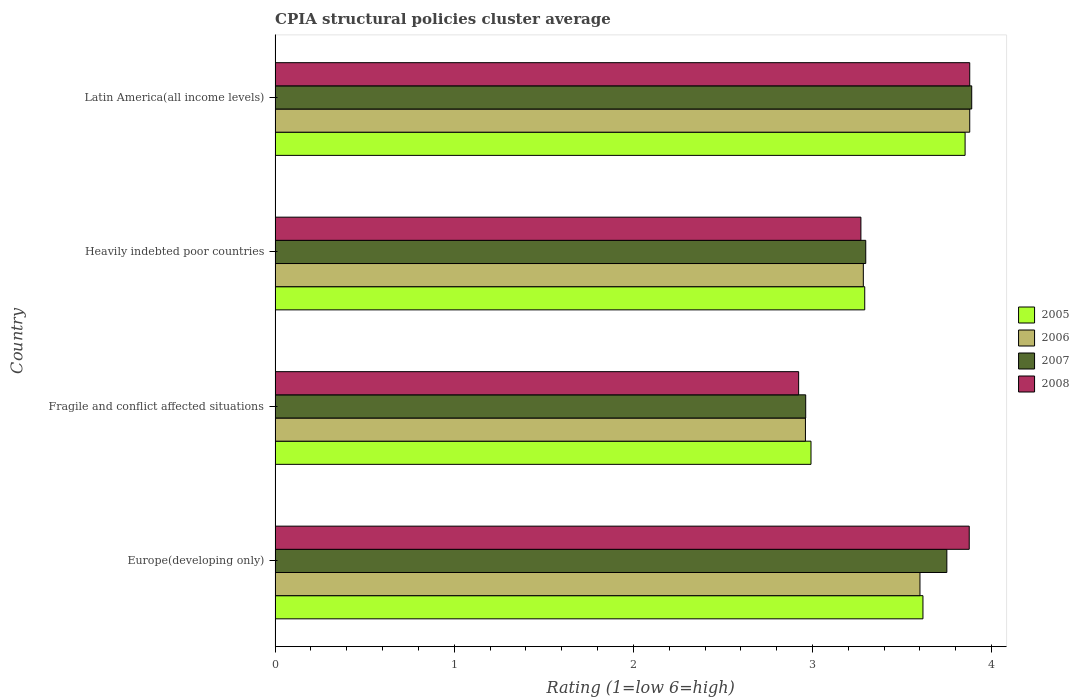How many groups of bars are there?
Give a very brief answer. 4. Are the number of bars per tick equal to the number of legend labels?
Provide a short and direct response. Yes. Are the number of bars on each tick of the Y-axis equal?
Your answer should be compact. Yes. How many bars are there on the 3rd tick from the top?
Keep it short and to the point. 4. What is the label of the 3rd group of bars from the top?
Provide a short and direct response. Fragile and conflict affected situations. In how many cases, is the number of bars for a given country not equal to the number of legend labels?
Make the answer very short. 0. What is the CPIA rating in 2008 in Europe(developing only)?
Provide a short and direct response. 3.88. Across all countries, what is the maximum CPIA rating in 2006?
Make the answer very short. 3.88. Across all countries, what is the minimum CPIA rating in 2005?
Ensure brevity in your answer.  2.99. In which country was the CPIA rating in 2006 maximum?
Offer a very short reply. Latin America(all income levels). In which country was the CPIA rating in 2005 minimum?
Your answer should be very brief. Fragile and conflict affected situations. What is the total CPIA rating in 2007 in the graph?
Keep it short and to the point. 13.9. What is the difference between the CPIA rating in 2007 in Europe(developing only) and that in Fragile and conflict affected situations?
Offer a terse response. 0.79. What is the difference between the CPIA rating in 2007 in Latin America(all income levels) and the CPIA rating in 2005 in Fragile and conflict affected situations?
Ensure brevity in your answer.  0.9. What is the average CPIA rating in 2008 per country?
Offer a very short reply. 3.49. What is the difference between the CPIA rating in 2007 and CPIA rating in 2005 in Latin America(all income levels)?
Make the answer very short. 0.04. What is the ratio of the CPIA rating in 2006 in Heavily indebted poor countries to that in Latin America(all income levels)?
Keep it short and to the point. 0.85. What is the difference between the highest and the second highest CPIA rating in 2007?
Provide a succinct answer. 0.14. What is the difference between the highest and the lowest CPIA rating in 2007?
Give a very brief answer. 0.93. In how many countries, is the CPIA rating in 2006 greater than the average CPIA rating in 2006 taken over all countries?
Your response must be concise. 2. Is the sum of the CPIA rating in 2005 in Europe(developing only) and Latin America(all income levels) greater than the maximum CPIA rating in 2006 across all countries?
Keep it short and to the point. Yes. Is it the case that in every country, the sum of the CPIA rating in 2005 and CPIA rating in 2007 is greater than the sum of CPIA rating in 2006 and CPIA rating in 2008?
Provide a short and direct response. No. Is it the case that in every country, the sum of the CPIA rating in 2005 and CPIA rating in 2007 is greater than the CPIA rating in 2006?
Make the answer very short. Yes. How many bars are there?
Your answer should be compact. 16. Are all the bars in the graph horizontal?
Provide a short and direct response. Yes. Are the values on the major ticks of X-axis written in scientific E-notation?
Provide a succinct answer. No. Does the graph contain grids?
Provide a succinct answer. No. Where does the legend appear in the graph?
Provide a short and direct response. Center right. How many legend labels are there?
Offer a terse response. 4. What is the title of the graph?
Ensure brevity in your answer.  CPIA structural policies cluster average. What is the Rating (1=low 6=high) in 2005 in Europe(developing only)?
Your response must be concise. 3.62. What is the Rating (1=low 6=high) of 2006 in Europe(developing only)?
Offer a very short reply. 3.6. What is the Rating (1=low 6=high) of 2007 in Europe(developing only)?
Make the answer very short. 3.75. What is the Rating (1=low 6=high) of 2008 in Europe(developing only)?
Offer a very short reply. 3.88. What is the Rating (1=low 6=high) of 2005 in Fragile and conflict affected situations?
Make the answer very short. 2.99. What is the Rating (1=low 6=high) of 2006 in Fragile and conflict affected situations?
Offer a very short reply. 2.96. What is the Rating (1=low 6=high) in 2007 in Fragile and conflict affected situations?
Give a very brief answer. 2.96. What is the Rating (1=low 6=high) in 2008 in Fragile and conflict affected situations?
Make the answer very short. 2.92. What is the Rating (1=low 6=high) in 2005 in Heavily indebted poor countries?
Keep it short and to the point. 3.29. What is the Rating (1=low 6=high) of 2006 in Heavily indebted poor countries?
Provide a short and direct response. 3.28. What is the Rating (1=low 6=high) in 2007 in Heavily indebted poor countries?
Provide a short and direct response. 3.3. What is the Rating (1=low 6=high) of 2008 in Heavily indebted poor countries?
Your answer should be compact. 3.27. What is the Rating (1=low 6=high) in 2005 in Latin America(all income levels)?
Provide a short and direct response. 3.85. What is the Rating (1=low 6=high) in 2006 in Latin America(all income levels)?
Your answer should be very brief. 3.88. What is the Rating (1=low 6=high) in 2007 in Latin America(all income levels)?
Provide a succinct answer. 3.89. What is the Rating (1=low 6=high) in 2008 in Latin America(all income levels)?
Offer a very short reply. 3.88. Across all countries, what is the maximum Rating (1=low 6=high) in 2005?
Offer a very short reply. 3.85. Across all countries, what is the maximum Rating (1=low 6=high) of 2006?
Give a very brief answer. 3.88. Across all countries, what is the maximum Rating (1=low 6=high) of 2007?
Your answer should be compact. 3.89. Across all countries, what is the maximum Rating (1=low 6=high) in 2008?
Your response must be concise. 3.88. Across all countries, what is the minimum Rating (1=low 6=high) of 2005?
Provide a succinct answer. 2.99. Across all countries, what is the minimum Rating (1=low 6=high) of 2006?
Give a very brief answer. 2.96. Across all countries, what is the minimum Rating (1=low 6=high) of 2007?
Provide a short and direct response. 2.96. Across all countries, what is the minimum Rating (1=low 6=high) of 2008?
Offer a very short reply. 2.92. What is the total Rating (1=low 6=high) in 2005 in the graph?
Give a very brief answer. 13.75. What is the total Rating (1=low 6=high) in 2006 in the graph?
Give a very brief answer. 13.72. What is the total Rating (1=low 6=high) in 2007 in the graph?
Provide a short and direct response. 13.9. What is the total Rating (1=low 6=high) in 2008 in the graph?
Offer a very short reply. 13.95. What is the difference between the Rating (1=low 6=high) in 2005 in Europe(developing only) and that in Fragile and conflict affected situations?
Ensure brevity in your answer.  0.62. What is the difference between the Rating (1=low 6=high) of 2006 in Europe(developing only) and that in Fragile and conflict affected situations?
Ensure brevity in your answer.  0.64. What is the difference between the Rating (1=low 6=high) in 2007 in Europe(developing only) and that in Fragile and conflict affected situations?
Provide a succinct answer. 0.79. What is the difference between the Rating (1=low 6=high) in 2008 in Europe(developing only) and that in Fragile and conflict affected situations?
Provide a succinct answer. 0.95. What is the difference between the Rating (1=low 6=high) of 2005 in Europe(developing only) and that in Heavily indebted poor countries?
Provide a short and direct response. 0.33. What is the difference between the Rating (1=low 6=high) in 2006 in Europe(developing only) and that in Heavily indebted poor countries?
Provide a short and direct response. 0.32. What is the difference between the Rating (1=low 6=high) in 2007 in Europe(developing only) and that in Heavily indebted poor countries?
Provide a short and direct response. 0.45. What is the difference between the Rating (1=low 6=high) of 2008 in Europe(developing only) and that in Heavily indebted poor countries?
Provide a short and direct response. 0.6. What is the difference between the Rating (1=low 6=high) of 2005 in Europe(developing only) and that in Latin America(all income levels)?
Make the answer very short. -0.24. What is the difference between the Rating (1=low 6=high) of 2006 in Europe(developing only) and that in Latin America(all income levels)?
Your answer should be compact. -0.28. What is the difference between the Rating (1=low 6=high) of 2007 in Europe(developing only) and that in Latin America(all income levels)?
Provide a succinct answer. -0.14. What is the difference between the Rating (1=low 6=high) of 2008 in Europe(developing only) and that in Latin America(all income levels)?
Provide a short and direct response. -0. What is the difference between the Rating (1=low 6=high) of 2006 in Fragile and conflict affected situations and that in Heavily indebted poor countries?
Keep it short and to the point. -0.32. What is the difference between the Rating (1=low 6=high) in 2007 in Fragile and conflict affected situations and that in Heavily indebted poor countries?
Give a very brief answer. -0.34. What is the difference between the Rating (1=low 6=high) in 2008 in Fragile and conflict affected situations and that in Heavily indebted poor countries?
Provide a short and direct response. -0.35. What is the difference between the Rating (1=low 6=high) in 2005 in Fragile and conflict affected situations and that in Latin America(all income levels)?
Offer a very short reply. -0.86. What is the difference between the Rating (1=low 6=high) in 2006 in Fragile and conflict affected situations and that in Latin America(all income levels)?
Your answer should be compact. -0.92. What is the difference between the Rating (1=low 6=high) in 2007 in Fragile and conflict affected situations and that in Latin America(all income levels)?
Make the answer very short. -0.93. What is the difference between the Rating (1=low 6=high) in 2008 in Fragile and conflict affected situations and that in Latin America(all income levels)?
Ensure brevity in your answer.  -0.96. What is the difference between the Rating (1=low 6=high) of 2005 in Heavily indebted poor countries and that in Latin America(all income levels)?
Your answer should be compact. -0.56. What is the difference between the Rating (1=low 6=high) in 2006 in Heavily indebted poor countries and that in Latin America(all income levels)?
Give a very brief answer. -0.59. What is the difference between the Rating (1=low 6=high) of 2007 in Heavily indebted poor countries and that in Latin America(all income levels)?
Ensure brevity in your answer.  -0.59. What is the difference between the Rating (1=low 6=high) of 2008 in Heavily indebted poor countries and that in Latin America(all income levels)?
Provide a succinct answer. -0.61. What is the difference between the Rating (1=low 6=high) of 2005 in Europe(developing only) and the Rating (1=low 6=high) of 2006 in Fragile and conflict affected situations?
Your answer should be very brief. 0.66. What is the difference between the Rating (1=low 6=high) in 2005 in Europe(developing only) and the Rating (1=low 6=high) in 2007 in Fragile and conflict affected situations?
Give a very brief answer. 0.65. What is the difference between the Rating (1=low 6=high) in 2005 in Europe(developing only) and the Rating (1=low 6=high) in 2008 in Fragile and conflict affected situations?
Your response must be concise. 0.69. What is the difference between the Rating (1=low 6=high) of 2006 in Europe(developing only) and the Rating (1=low 6=high) of 2007 in Fragile and conflict affected situations?
Your answer should be very brief. 0.64. What is the difference between the Rating (1=low 6=high) in 2006 in Europe(developing only) and the Rating (1=low 6=high) in 2008 in Fragile and conflict affected situations?
Your answer should be very brief. 0.68. What is the difference between the Rating (1=low 6=high) of 2007 in Europe(developing only) and the Rating (1=low 6=high) of 2008 in Fragile and conflict affected situations?
Your response must be concise. 0.83. What is the difference between the Rating (1=low 6=high) in 2005 in Europe(developing only) and the Rating (1=low 6=high) in 2006 in Heavily indebted poor countries?
Make the answer very short. 0.33. What is the difference between the Rating (1=low 6=high) in 2005 in Europe(developing only) and the Rating (1=low 6=high) in 2007 in Heavily indebted poor countries?
Your answer should be compact. 0.32. What is the difference between the Rating (1=low 6=high) in 2005 in Europe(developing only) and the Rating (1=low 6=high) in 2008 in Heavily indebted poor countries?
Provide a short and direct response. 0.35. What is the difference between the Rating (1=low 6=high) of 2006 in Europe(developing only) and the Rating (1=low 6=high) of 2007 in Heavily indebted poor countries?
Make the answer very short. 0.3. What is the difference between the Rating (1=low 6=high) of 2006 in Europe(developing only) and the Rating (1=low 6=high) of 2008 in Heavily indebted poor countries?
Provide a succinct answer. 0.33. What is the difference between the Rating (1=low 6=high) in 2007 in Europe(developing only) and the Rating (1=low 6=high) in 2008 in Heavily indebted poor countries?
Give a very brief answer. 0.48. What is the difference between the Rating (1=low 6=high) of 2005 in Europe(developing only) and the Rating (1=low 6=high) of 2006 in Latin America(all income levels)?
Offer a very short reply. -0.26. What is the difference between the Rating (1=low 6=high) in 2005 in Europe(developing only) and the Rating (1=low 6=high) in 2007 in Latin America(all income levels)?
Keep it short and to the point. -0.27. What is the difference between the Rating (1=low 6=high) in 2005 in Europe(developing only) and the Rating (1=low 6=high) in 2008 in Latin America(all income levels)?
Your answer should be compact. -0.26. What is the difference between the Rating (1=low 6=high) of 2006 in Europe(developing only) and the Rating (1=low 6=high) of 2007 in Latin America(all income levels)?
Ensure brevity in your answer.  -0.29. What is the difference between the Rating (1=low 6=high) of 2006 in Europe(developing only) and the Rating (1=low 6=high) of 2008 in Latin America(all income levels)?
Keep it short and to the point. -0.28. What is the difference between the Rating (1=low 6=high) of 2007 in Europe(developing only) and the Rating (1=low 6=high) of 2008 in Latin America(all income levels)?
Your response must be concise. -0.13. What is the difference between the Rating (1=low 6=high) in 2005 in Fragile and conflict affected situations and the Rating (1=low 6=high) in 2006 in Heavily indebted poor countries?
Your response must be concise. -0.29. What is the difference between the Rating (1=low 6=high) in 2005 in Fragile and conflict affected situations and the Rating (1=low 6=high) in 2007 in Heavily indebted poor countries?
Keep it short and to the point. -0.31. What is the difference between the Rating (1=low 6=high) of 2005 in Fragile and conflict affected situations and the Rating (1=low 6=high) of 2008 in Heavily indebted poor countries?
Your answer should be compact. -0.28. What is the difference between the Rating (1=low 6=high) in 2006 in Fragile and conflict affected situations and the Rating (1=low 6=high) in 2007 in Heavily indebted poor countries?
Make the answer very short. -0.34. What is the difference between the Rating (1=low 6=high) in 2006 in Fragile and conflict affected situations and the Rating (1=low 6=high) in 2008 in Heavily indebted poor countries?
Your answer should be compact. -0.31. What is the difference between the Rating (1=low 6=high) in 2007 in Fragile and conflict affected situations and the Rating (1=low 6=high) in 2008 in Heavily indebted poor countries?
Ensure brevity in your answer.  -0.31. What is the difference between the Rating (1=low 6=high) in 2005 in Fragile and conflict affected situations and the Rating (1=low 6=high) in 2006 in Latin America(all income levels)?
Give a very brief answer. -0.89. What is the difference between the Rating (1=low 6=high) of 2005 in Fragile and conflict affected situations and the Rating (1=low 6=high) of 2007 in Latin America(all income levels)?
Offer a terse response. -0.9. What is the difference between the Rating (1=low 6=high) in 2005 in Fragile and conflict affected situations and the Rating (1=low 6=high) in 2008 in Latin America(all income levels)?
Your response must be concise. -0.89. What is the difference between the Rating (1=low 6=high) in 2006 in Fragile and conflict affected situations and the Rating (1=low 6=high) in 2007 in Latin America(all income levels)?
Your response must be concise. -0.93. What is the difference between the Rating (1=low 6=high) of 2006 in Fragile and conflict affected situations and the Rating (1=low 6=high) of 2008 in Latin America(all income levels)?
Keep it short and to the point. -0.92. What is the difference between the Rating (1=low 6=high) in 2007 in Fragile and conflict affected situations and the Rating (1=low 6=high) in 2008 in Latin America(all income levels)?
Your answer should be compact. -0.92. What is the difference between the Rating (1=low 6=high) in 2005 in Heavily indebted poor countries and the Rating (1=low 6=high) in 2006 in Latin America(all income levels)?
Provide a short and direct response. -0.59. What is the difference between the Rating (1=low 6=high) of 2005 in Heavily indebted poor countries and the Rating (1=low 6=high) of 2007 in Latin America(all income levels)?
Give a very brief answer. -0.6. What is the difference between the Rating (1=low 6=high) of 2005 in Heavily indebted poor countries and the Rating (1=low 6=high) of 2008 in Latin America(all income levels)?
Ensure brevity in your answer.  -0.59. What is the difference between the Rating (1=low 6=high) of 2006 in Heavily indebted poor countries and the Rating (1=low 6=high) of 2007 in Latin America(all income levels)?
Give a very brief answer. -0.61. What is the difference between the Rating (1=low 6=high) in 2006 in Heavily indebted poor countries and the Rating (1=low 6=high) in 2008 in Latin America(all income levels)?
Your answer should be compact. -0.59. What is the difference between the Rating (1=low 6=high) of 2007 in Heavily indebted poor countries and the Rating (1=low 6=high) of 2008 in Latin America(all income levels)?
Offer a terse response. -0.58. What is the average Rating (1=low 6=high) of 2005 per country?
Provide a short and direct response. 3.44. What is the average Rating (1=low 6=high) in 2006 per country?
Ensure brevity in your answer.  3.43. What is the average Rating (1=low 6=high) of 2007 per country?
Your answer should be compact. 3.47. What is the average Rating (1=low 6=high) of 2008 per country?
Offer a very short reply. 3.49. What is the difference between the Rating (1=low 6=high) in 2005 and Rating (1=low 6=high) in 2006 in Europe(developing only)?
Offer a very short reply. 0.02. What is the difference between the Rating (1=low 6=high) of 2005 and Rating (1=low 6=high) of 2007 in Europe(developing only)?
Your answer should be compact. -0.13. What is the difference between the Rating (1=low 6=high) of 2005 and Rating (1=low 6=high) of 2008 in Europe(developing only)?
Keep it short and to the point. -0.26. What is the difference between the Rating (1=low 6=high) in 2006 and Rating (1=low 6=high) in 2007 in Europe(developing only)?
Provide a short and direct response. -0.15. What is the difference between the Rating (1=low 6=high) in 2006 and Rating (1=low 6=high) in 2008 in Europe(developing only)?
Give a very brief answer. -0.28. What is the difference between the Rating (1=low 6=high) of 2007 and Rating (1=low 6=high) of 2008 in Europe(developing only)?
Offer a very short reply. -0.12. What is the difference between the Rating (1=low 6=high) in 2005 and Rating (1=low 6=high) in 2006 in Fragile and conflict affected situations?
Make the answer very short. 0.03. What is the difference between the Rating (1=low 6=high) in 2005 and Rating (1=low 6=high) in 2007 in Fragile and conflict affected situations?
Offer a very short reply. 0.03. What is the difference between the Rating (1=low 6=high) of 2005 and Rating (1=low 6=high) of 2008 in Fragile and conflict affected situations?
Your answer should be very brief. 0.07. What is the difference between the Rating (1=low 6=high) in 2006 and Rating (1=low 6=high) in 2007 in Fragile and conflict affected situations?
Your response must be concise. -0. What is the difference between the Rating (1=low 6=high) of 2006 and Rating (1=low 6=high) of 2008 in Fragile and conflict affected situations?
Offer a terse response. 0.04. What is the difference between the Rating (1=low 6=high) in 2007 and Rating (1=low 6=high) in 2008 in Fragile and conflict affected situations?
Your answer should be compact. 0.04. What is the difference between the Rating (1=low 6=high) of 2005 and Rating (1=low 6=high) of 2006 in Heavily indebted poor countries?
Keep it short and to the point. 0.01. What is the difference between the Rating (1=low 6=high) in 2005 and Rating (1=low 6=high) in 2007 in Heavily indebted poor countries?
Provide a short and direct response. -0.01. What is the difference between the Rating (1=low 6=high) of 2005 and Rating (1=low 6=high) of 2008 in Heavily indebted poor countries?
Make the answer very short. 0.02. What is the difference between the Rating (1=low 6=high) of 2006 and Rating (1=low 6=high) of 2007 in Heavily indebted poor countries?
Your answer should be compact. -0.01. What is the difference between the Rating (1=low 6=high) in 2006 and Rating (1=low 6=high) in 2008 in Heavily indebted poor countries?
Your answer should be compact. 0.01. What is the difference between the Rating (1=low 6=high) of 2007 and Rating (1=low 6=high) of 2008 in Heavily indebted poor countries?
Make the answer very short. 0.03. What is the difference between the Rating (1=low 6=high) of 2005 and Rating (1=low 6=high) of 2006 in Latin America(all income levels)?
Provide a short and direct response. -0.03. What is the difference between the Rating (1=low 6=high) of 2005 and Rating (1=low 6=high) of 2007 in Latin America(all income levels)?
Your answer should be very brief. -0.04. What is the difference between the Rating (1=low 6=high) of 2005 and Rating (1=low 6=high) of 2008 in Latin America(all income levels)?
Keep it short and to the point. -0.03. What is the difference between the Rating (1=low 6=high) in 2006 and Rating (1=low 6=high) in 2007 in Latin America(all income levels)?
Your answer should be compact. -0.01. What is the difference between the Rating (1=low 6=high) of 2007 and Rating (1=low 6=high) of 2008 in Latin America(all income levels)?
Your response must be concise. 0.01. What is the ratio of the Rating (1=low 6=high) in 2005 in Europe(developing only) to that in Fragile and conflict affected situations?
Your answer should be very brief. 1.21. What is the ratio of the Rating (1=low 6=high) of 2006 in Europe(developing only) to that in Fragile and conflict affected situations?
Provide a short and direct response. 1.22. What is the ratio of the Rating (1=low 6=high) of 2007 in Europe(developing only) to that in Fragile and conflict affected situations?
Ensure brevity in your answer.  1.27. What is the ratio of the Rating (1=low 6=high) of 2008 in Europe(developing only) to that in Fragile and conflict affected situations?
Ensure brevity in your answer.  1.33. What is the ratio of the Rating (1=low 6=high) in 2005 in Europe(developing only) to that in Heavily indebted poor countries?
Ensure brevity in your answer.  1.1. What is the ratio of the Rating (1=low 6=high) in 2006 in Europe(developing only) to that in Heavily indebted poor countries?
Make the answer very short. 1.1. What is the ratio of the Rating (1=low 6=high) of 2007 in Europe(developing only) to that in Heavily indebted poor countries?
Provide a succinct answer. 1.14. What is the ratio of the Rating (1=low 6=high) of 2008 in Europe(developing only) to that in Heavily indebted poor countries?
Your response must be concise. 1.18. What is the ratio of the Rating (1=low 6=high) in 2005 in Europe(developing only) to that in Latin America(all income levels)?
Your response must be concise. 0.94. What is the ratio of the Rating (1=low 6=high) of 2006 in Europe(developing only) to that in Latin America(all income levels)?
Your response must be concise. 0.93. What is the ratio of the Rating (1=low 6=high) in 2007 in Europe(developing only) to that in Latin America(all income levels)?
Your response must be concise. 0.96. What is the ratio of the Rating (1=low 6=high) of 2005 in Fragile and conflict affected situations to that in Heavily indebted poor countries?
Make the answer very short. 0.91. What is the ratio of the Rating (1=low 6=high) in 2006 in Fragile and conflict affected situations to that in Heavily indebted poor countries?
Your response must be concise. 0.9. What is the ratio of the Rating (1=low 6=high) of 2007 in Fragile and conflict affected situations to that in Heavily indebted poor countries?
Give a very brief answer. 0.9. What is the ratio of the Rating (1=low 6=high) in 2008 in Fragile and conflict affected situations to that in Heavily indebted poor countries?
Your answer should be very brief. 0.89. What is the ratio of the Rating (1=low 6=high) in 2005 in Fragile and conflict affected situations to that in Latin America(all income levels)?
Make the answer very short. 0.78. What is the ratio of the Rating (1=low 6=high) in 2006 in Fragile and conflict affected situations to that in Latin America(all income levels)?
Your answer should be very brief. 0.76. What is the ratio of the Rating (1=low 6=high) of 2007 in Fragile and conflict affected situations to that in Latin America(all income levels)?
Provide a succinct answer. 0.76. What is the ratio of the Rating (1=low 6=high) of 2008 in Fragile and conflict affected situations to that in Latin America(all income levels)?
Offer a very short reply. 0.75. What is the ratio of the Rating (1=low 6=high) in 2005 in Heavily indebted poor countries to that in Latin America(all income levels)?
Offer a terse response. 0.85. What is the ratio of the Rating (1=low 6=high) in 2006 in Heavily indebted poor countries to that in Latin America(all income levels)?
Make the answer very short. 0.85. What is the ratio of the Rating (1=low 6=high) in 2007 in Heavily indebted poor countries to that in Latin America(all income levels)?
Your response must be concise. 0.85. What is the ratio of the Rating (1=low 6=high) of 2008 in Heavily indebted poor countries to that in Latin America(all income levels)?
Make the answer very short. 0.84. What is the difference between the highest and the second highest Rating (1=low 6=high) of 2005?
Make the answer very short. 0.24. What is the difference between the highest and the second highest Rating (1=low 6=high) of 2006?
Provide a succinct answer. 0.28. What is the difference between the highest and the second highest Rating (1=low 6=high) of 2007?
Offer a terse response. 0.14. What is the difference between the highest and the second highest Rating (1=low 6=high) in 2008?
Offer a terse response. 0. What is the difference between the highest and the lowest Rating (1=low 6=high) in 2005?
Keep it short and to the point. 0.86. What is the difference between the highest and the lowest Rating (1=low 6=high) in 2006?
Your answer should be very brief. 0.92. What is the difference between the highest and the lowest Rating (1=low 6=high) of 2007?
Make the answer very short. 0.93. What is the difference between the highest and the lowest Rating (1=low 6=high) in 2008?
Provide a succinct answer. 0.96. 